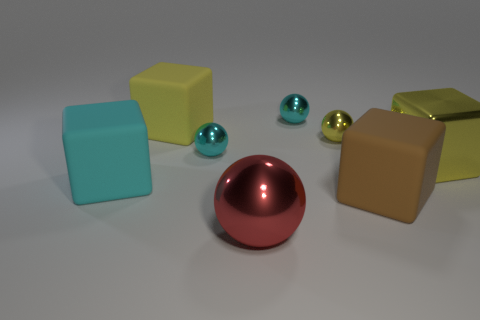Could you describe the material textures visible in the image? Certainly! In the image, the materials vary significantly. The cubes and cylinder appear to have a matte, slightly rough texture, suggesting a rubber-like material. In contrast, the spheres exhibit a smooth, reflective surface, likely indicating a metallic composition. 